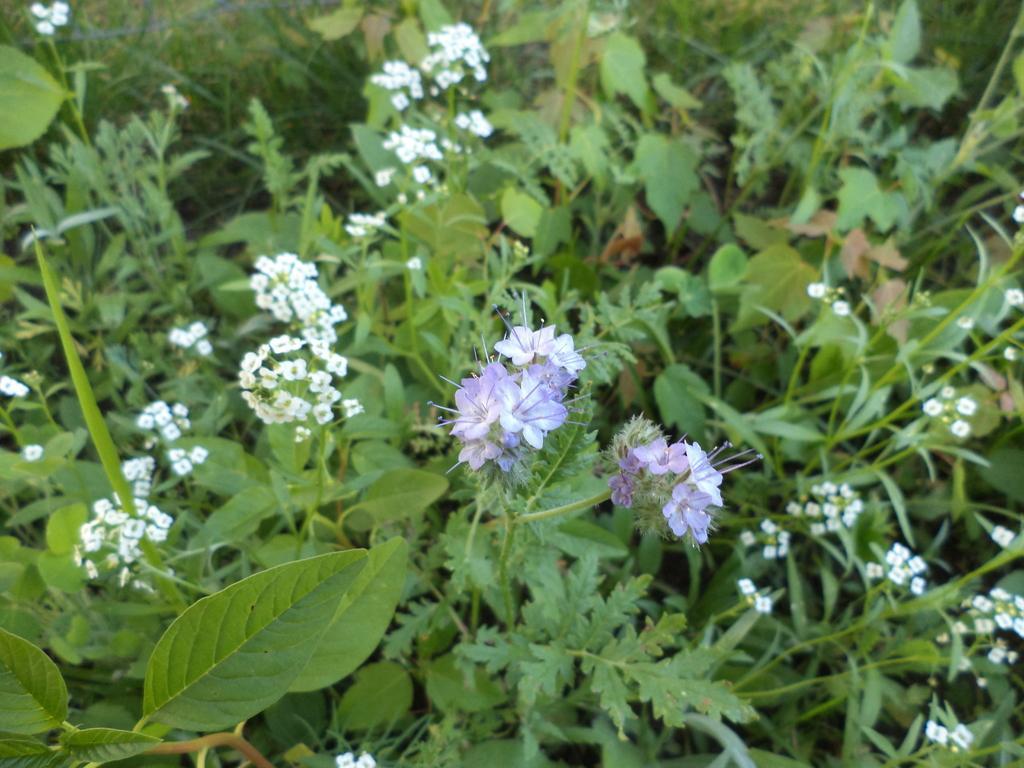Can you describe this image briefly? In this image I can see few flowers which are purple and white in color to the plants which are green in color. 